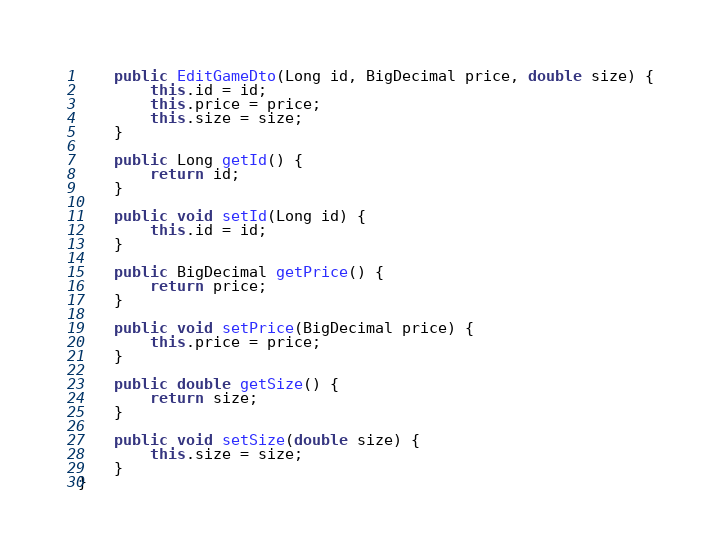<code> <loc_0><loc_0><loc_500><loc_500><_Java_>
    public EditGameDto(Long id, BigDecimal price, double size) {
        this.id = id;
        this.price = price;
        this.size = size;
    }

    public Long getId() {
        return id;
    }

    public void setId(Long id) {
        this.id = id;
    }

    public BigDecimal getPrice() {
        return price;
    }

    public void setPrice(BigDecimal price) {
        this.price = price;
    }

    public double getSize() {
        return size;
    }

    public void setSize(double size) {
        this.size = size;
    }
}
</code> 